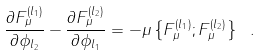Convert formula to latex. <formula><loc_0><loc_0><loc_500><loc_500>\frac { \partial F ^ { ( l _ { 1 } ) } _ { \mu } } { \partial \phi _ { l _ { 2 } } } - \frac { \partial F ^ { ( l _ { 2 } ) } _ { \mu } } { \partial \phi _ { l _ { 1 } } } = - \mu \left \{ F _ { \mu } ^ { ( l _ { 1 } ) } ; F _ { \mu } ^ { ( l _ { 2 } ) } \right \} \ .</formula> 